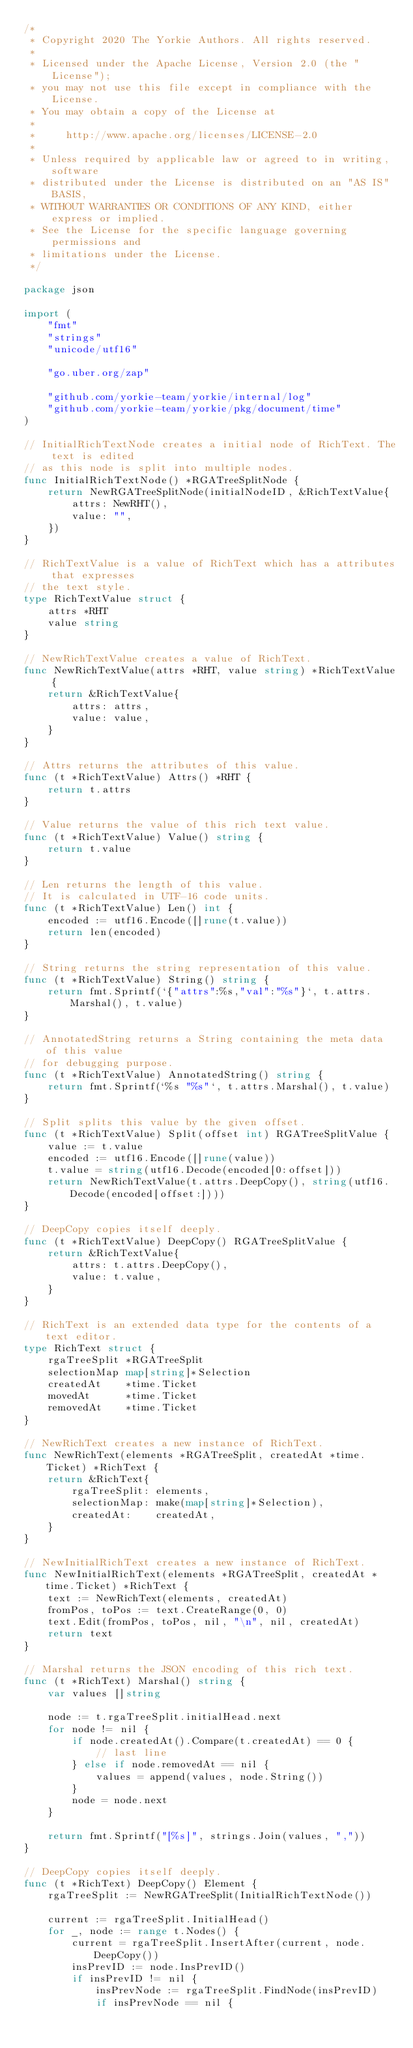Convert code to text. <code><loc_0><loc_0><loc_500><loc_500><_Go_>/*
 * Copyright 2020 The Yorkie Authors. All rights reserved.
 *
 * Licensed under the Apache License, Version 2.0 (the "License");
 * you may not use this file except in compliance with the License.
 * You may obtain a copy of the License at
 *
 *     http://www.apache.org/licenses/LICENSE-2.0
 *
 * Unless required by applicable law or agreed to in writing, software
 * distributed under the License is distributed on an "AS IS" BASIS,
 * WITHOUT WARRANTIES OR CONDITIONS OF ANY KIND, either express or implied.
 * See the License for the specific language governing permissions and
 * limitations under the License.
 */

package json

import (
	"fmt"
	"strings"
	"unicode/utf16"

	"go.uber.org/zap"

	"github.com/yorkie-team/yorkie/internal/log"
	"github.com/yorkie-team/yorkie/pkg/document/time"
)

// InitialRichTextNode creates a initial node of RichText. The text is edited
// as this node is split into multiple nodes.
func InitialRichTextNode() *RGATreeSplitNode {
	return NewRGATreeSplitNode(initialNodeID, &RichTextValue{
		attrs: NewRHT(),
		value: "",
	})
}

// RichTextValue is a value of RichText which has a attributes that expresses
// the text style.
type RichTextValue struct {
	attrs *RHT
	value string
}

// NewRichTextValue creates a value of RichText.
func NewRichTextValue(attrs *RHT, value string) *RichTextValue {
	return &RichTextValue{
		attrs: attrs,
		value: value,
	}
}

// Attrs returns the attributes of this value.
func (t *RichTextValue) Attrs() *RHT {
	return t.attrs
}

// Value returns the value of this rich text value.
func (t *RichTextValue) Value() string {
	return t.value
}

// Len returns the length of this value.
// It is calculated in UTF-16 code units.
func (t *RichTextValue) Len() int {
	encoded := utf16.Encode([]rune(t.value))
	return len(encoded)
}

// String returns the string representation of this value.
func (t *RichTextValue) String() string {
	return fmt.Sprintf(`{"attrs":%s,"val":"%s"}`, t.attrs.Marshal(), t.value)
}

// AnnotatedString returns a String containing the meta data of this value
// for debugging purpose.
func (t *RichTextValue) AnnotatedString() string {
	return fmt.Sprintf(`%s "%s"`, t.attrs.Marshal(), t.value)
}

// Split splits this value by the given offset.
func (t *RichTextValue) Split(offset int) RGATreeSplitValue {
	value := t.value
	encoded := utf16.Encode([]rune(value))
	t.value = string(utf16.Decode(encoded[0:offset]))
	return NewRichTextValue(t.attrs.DeepCopy(), string(utf16.Decode(encoded[offset:])))
}

// DeepCopy copies itself deeply.
func (t *RichTextValue) DeepCopy() RGATreeSplitValue {
	return &RichTextValue{
		attrs: t.attrs.DeepCopy(),
		value: t.value,
	}
}

// RichText is an extended data type for the contents of a text editor.
type RichText struct {
	rgaTreeSplit *RGATreeSplit
	selectionMap map[string]*Selection
	createdAt    *time.Ticket
	movedAt      *time.Ticket
	removedAt    *time.Ticket
}

// NewRichText creates a new instance of RichText.
func NewRichText(elements *RGATreeSplit, createdAt *time.Ticket) *RichText {
	return &RichText{
		rgaTreeSplit: elements,
		selectionMap: make(map[string]*Selection),
		createdAt:    createdAt,
	}
}

// NewInitialRichText creates a new instance of RichText.
func NewInitialRichText(elements *RGATreeSplit, createdAt *time.Ticket) *RichText {
	text := NewRichText(elements, createdAt)
	fromPos, toPos := text.CreateRange(0, 0)
	text.Edit(fromPos, toPos, nil, "\n", nil, createdAt)
	return text
}

// Marshal returns the JSON encoding of this rich text.
func (t *RichText) Marshal() string {
	var values []string

	node := t.rgaTreeSplit.initialHead.next
	for node != nil {
		if node.createdAt().Compare(t.createdAt) == 0 {
			// last line
		} else if node.removedAt == nil {
			values = append(values, node.String())
		}
		node = node.next
	}

	return fmt.Sprintf("[%s]", strings.Join(values, ","))
}

// DeepCopy copies itself deeply.
func (t *RichText) DeepCopy() Element {
	rgaTreeSplit := NewRGATreeSplit(InitialRichTextNode())

	current := rgaTreeSplit.InitialHead()
	for _, node := range t.Nodes() {
		current = rgaTreeSplit.InsertAfter(current, node.DeepCopy())
		insPrevID := node.InsPrevID()
		if insPrevID != nil {
			insPrevNode := rgaTreeSplit.FindNode(insPrevID)
			if insPrevNode == nil {</code> 